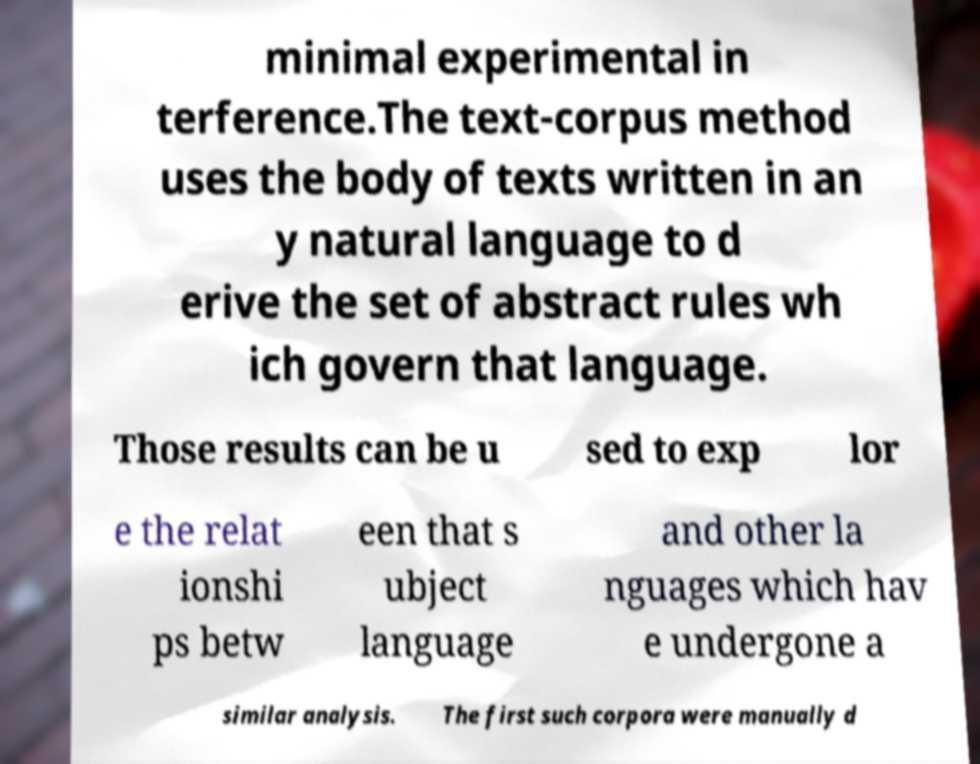Please read and relay the text visible in this image. What does it say? minimal experimental in terference.The text-corpus method uses the body of texts written in an y natural language to d erive the set of abstract rules wh ich govern that language. Those results can be u sed to exp lor e the relat ionshi ps betw een that s ubject language and other la nguages which hav e undergone a similar analysis. The first such corpora were manually d 